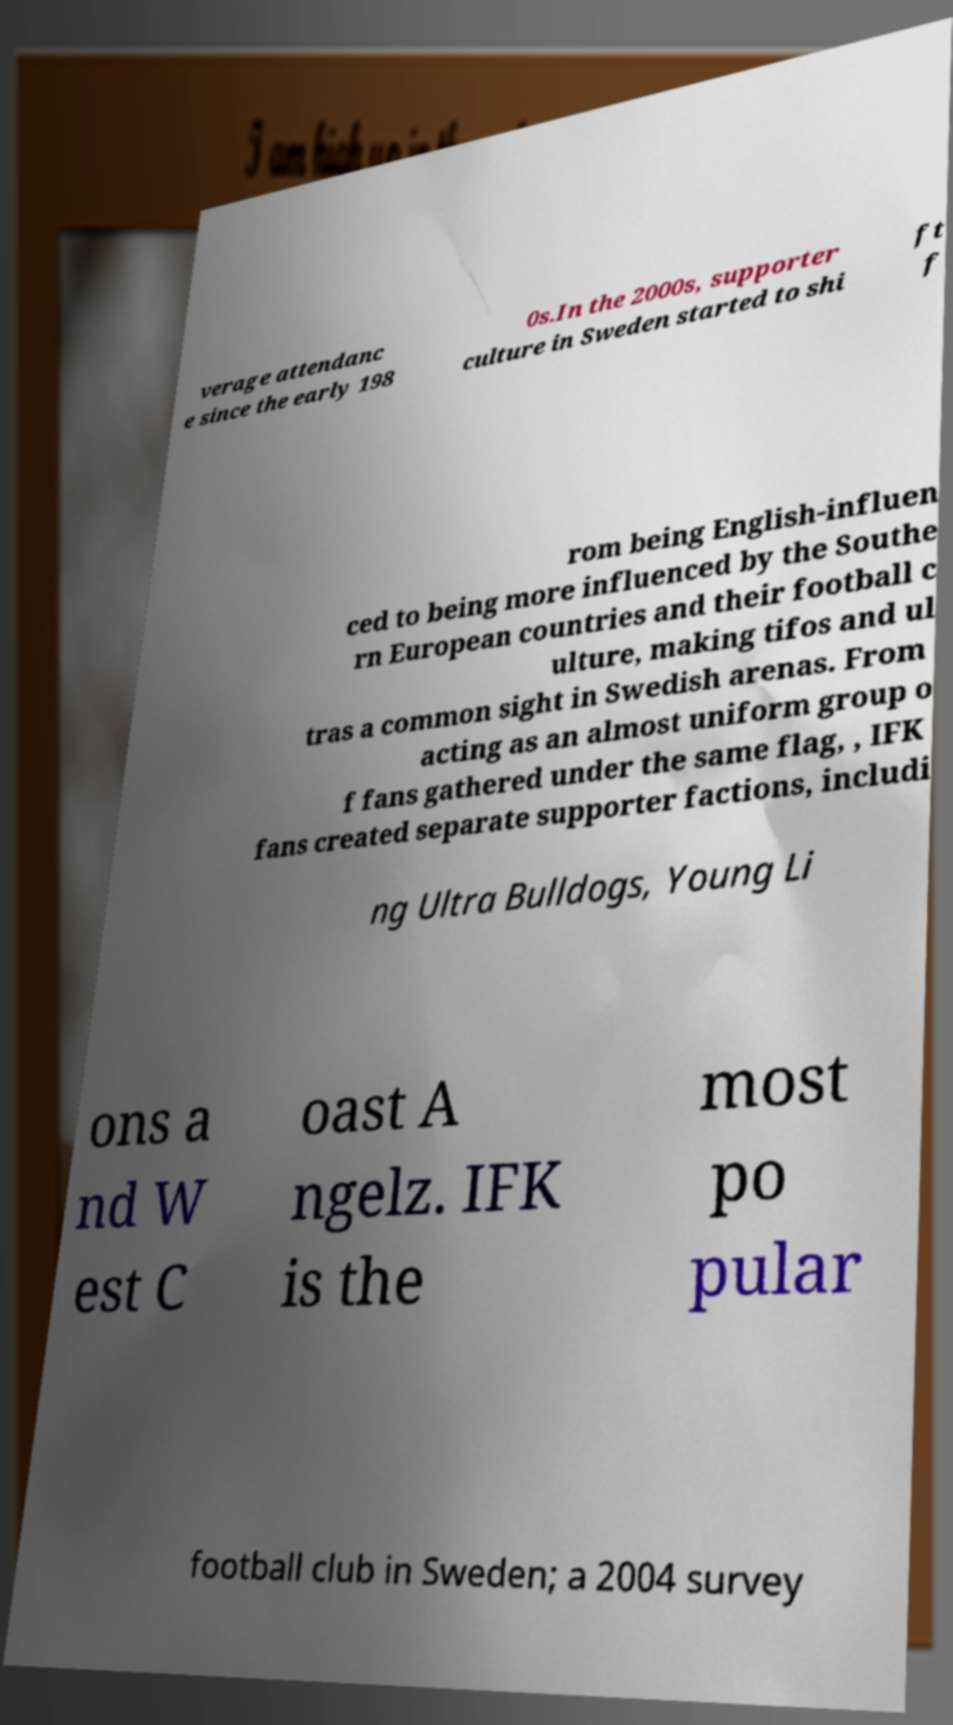Can you accurately transcribe the text from the provided image for me? verage attendanc e since the early 198 0s.In the 2000s, supporter culture in Sweden started to shi ft f rom being English-influen ced to being more influenced by the Southe rn European countries and their football c ulture, making tifos and ul tras a common sight in Swedish arenas. From acting as an almost uniform group o f fans gathered under the same flag, , IFK fans created separate supporter factions, includi ng Ultra Bulldogs, Young Li ons a nd W est C oast A ngelz. IFK is the most po pular football club in Sweden; a 2004 survey 